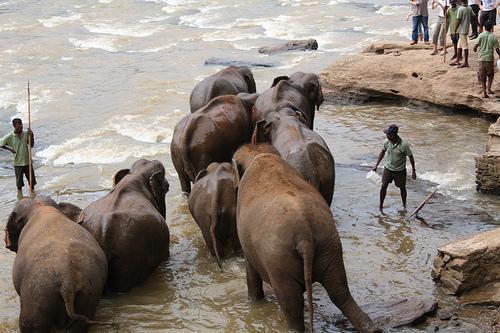How many peope are in the water?
Give a very brief answer. 2. How many elephants are there?
Give a very brief answer. 8. How many baby elephants are there?
Give a very brief answer. 1. 